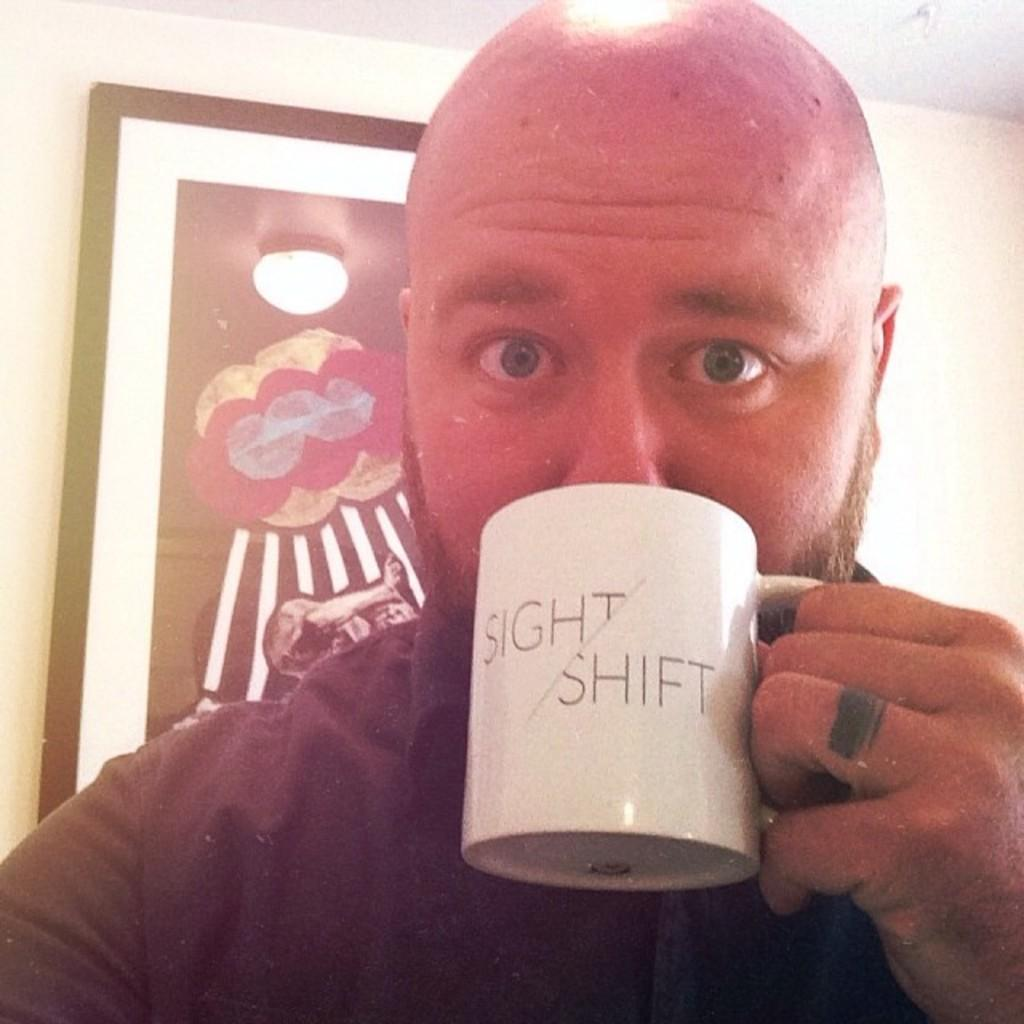<image>
Render a clear and concise summary of the photo. A bald bearded man drinking from a white coffee mug labeled 'Sight/Shift' 